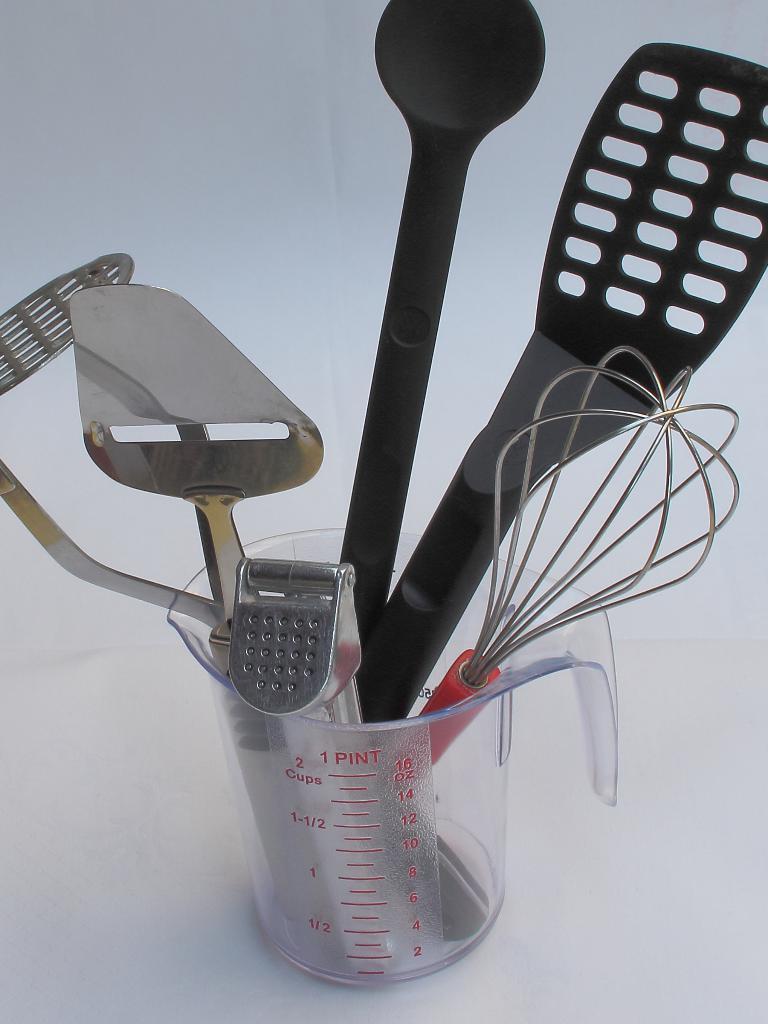Could you give a brief overview of what you see in this image? In the center of the image we can see a mug is present on the surface which contains spatulas and tuner. 